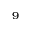Convert formula to latex. <formula><loc_0><loc_0><loc_500><loc_500>^ { 9 }</formula> 